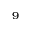Convert formula to latex. <formula><loc_0><loc_0><loc_500><loc_500>^ { 9 }</formula> 